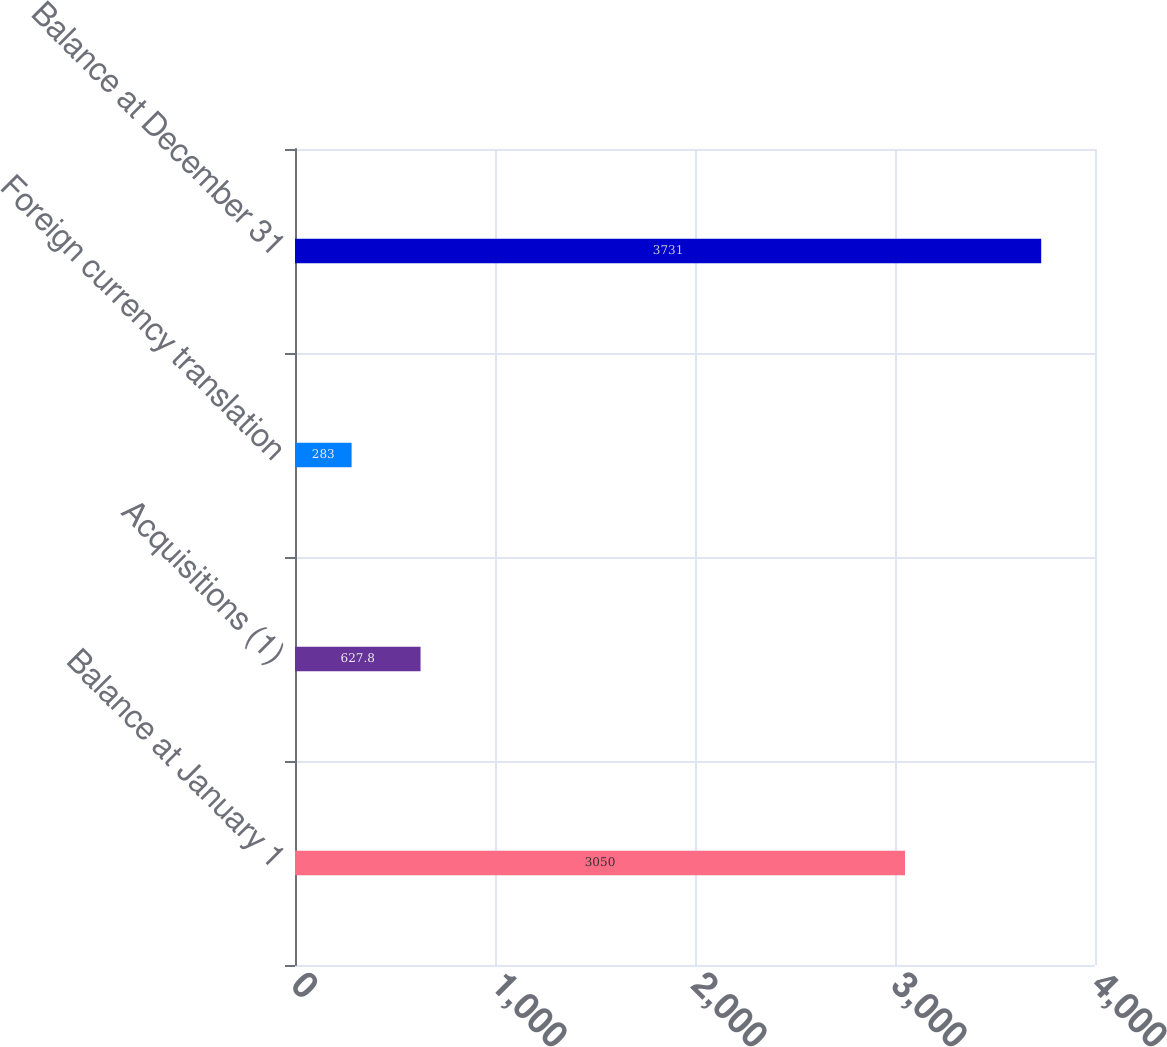Convert chart to OTSL. <chart><loc_0><loc_0><loc_500><loc_500><bar_chart><fcel>Balance at January 1<fcel>Acquisitions (1)<fcel>Foreign currency translation<fcel>Balance at December 31<nl><fcel>3050<fcel>627.8<fcel>283<fcel>3731<nl></chart> 